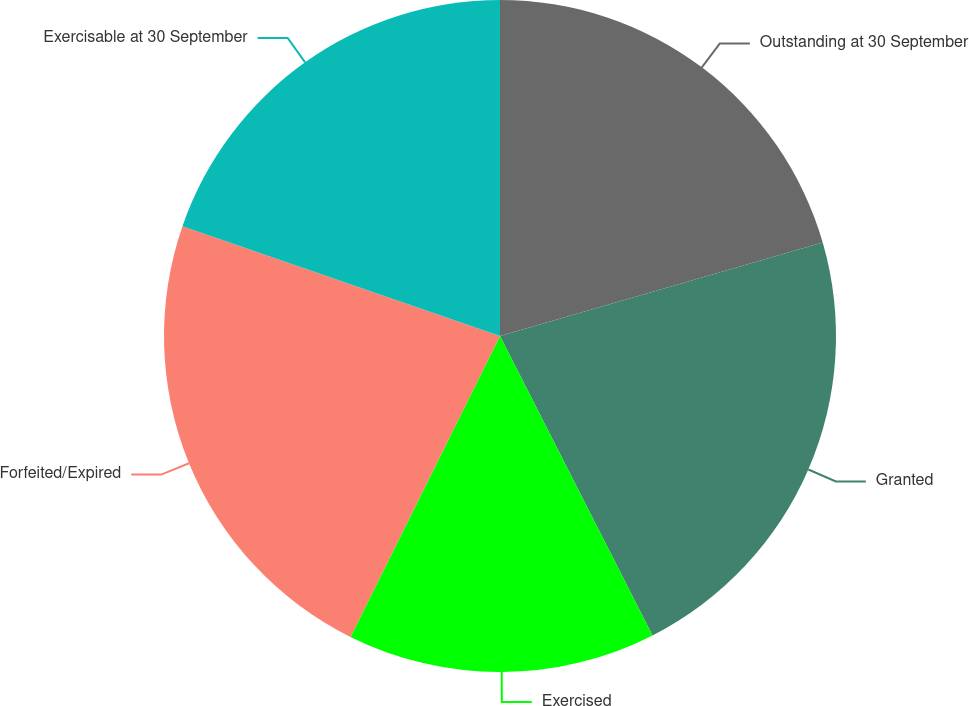<chart> <loc_0><loc_0><loc_500><loc_500><pie_chart><fcel>Outstanding at 30 September<fcel>Granted<fcel>Exercised<fcel>Forfeited/Expired<fcel>Exercisable at 30 September<nl><fcel>20.51%<fcel>21.99%<fcel>14.84%<fcel>22.96%<fcel>19.7%<nl></chart> 